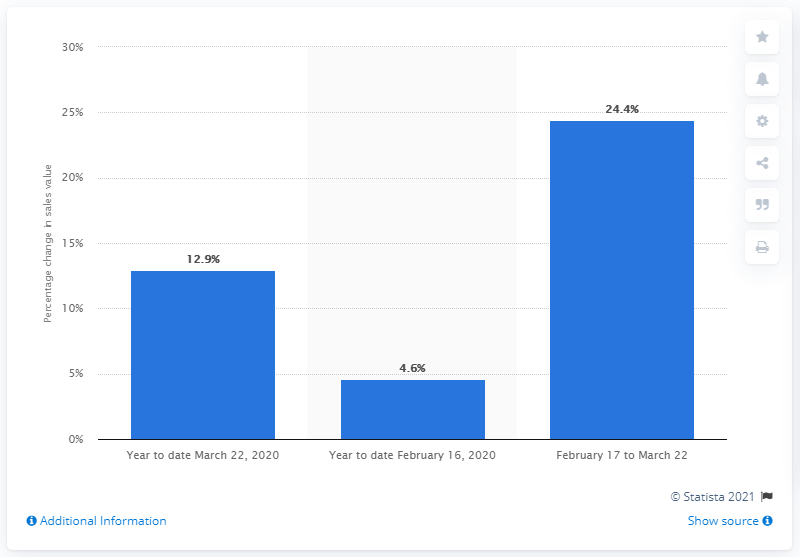Identify some key points in this picture. The change in sales value between February and March 2020 was an increase of 12.9%. 